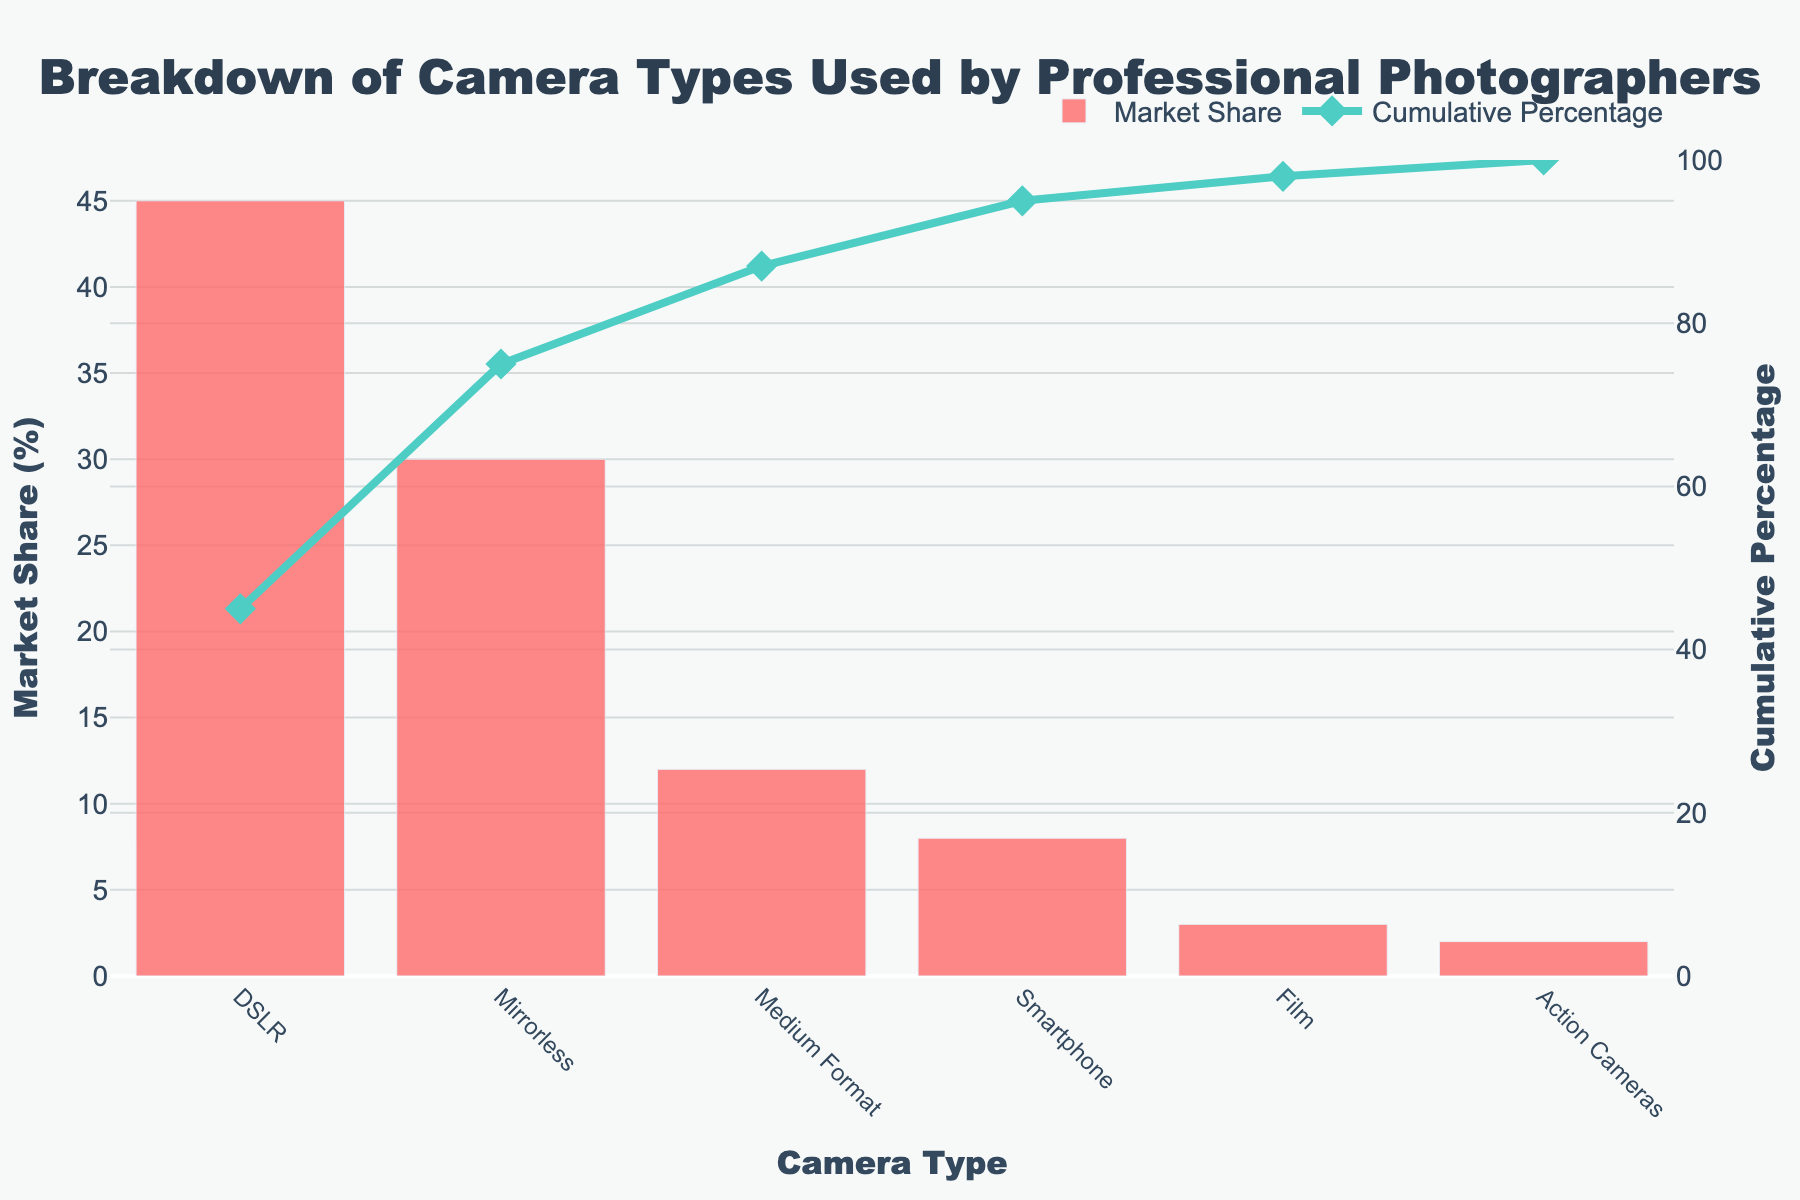What is the title of the figure? The title is usually located at the top of the figure. Here it states "Breakdown of Camera Types Used by Professional Photographers".
Answer: Breakdown of Camera Types Used by Professional Photographers Which camera type has the highest market share? The highest bar in the bar chart indicates the camera type with the highest market share, which is labeled underneath it.
Answer: DSLR What is the market share of mirrorless cameras? Look for the bar labeled "Mirrorless" on the x-axis and read off its height on the market share y-axis.
Answer: 30% How many camera types are represented in the figure? Count the distinct categories on the x-axis. There are six labels.
Answer: 6 What is the cumulative percentage for medium format cameras? Find the point corresponding to "Medium Format" on the x-axis and look for the related y-coordinate on the cumulative percentage line chart.
Answer: 87% Which camera types together make up more than 50% of the market? First, identify that 50% of the market share is surpassed by finding where the cumulative percentage line crosses above 50%. Then, list the camera types that together sum to more than 50%. DSLR and Mirrorless combined are 45% + 30% = 75%, which is more than half.
Answer: DSLR, Mirrorless By how much does the market share of DSLRs exceed the market share of smartphones? Look at the bars for both "DSLR" and "Smartphone" and subtract the market share of smartphones from that of DSLRs: 45% - 8%.
Answer: 37% What is the cumulative percentage after adding the market share of action cameras? Follow the cumulative line until you reach the "Action Cameras" label on the x-axis.
Answer: 100% Compare the market shares of Film and Action Cameras. Which is greater and by how much? Film has a market share of 3%, and Action Cameras have 2%. Subtract 2% from 3%.
Answer: Film by 1% How much does adding medium format cameras to the mix increase the cumulative percentage? Note the cumulative percentage just before Medium Format is added (DSLR + Mirrorless = 75%) and the cumulative percentage right after adding it. Subtract the initial total from the total including Medium Format: 87% - 75%.
Answer: 12% 